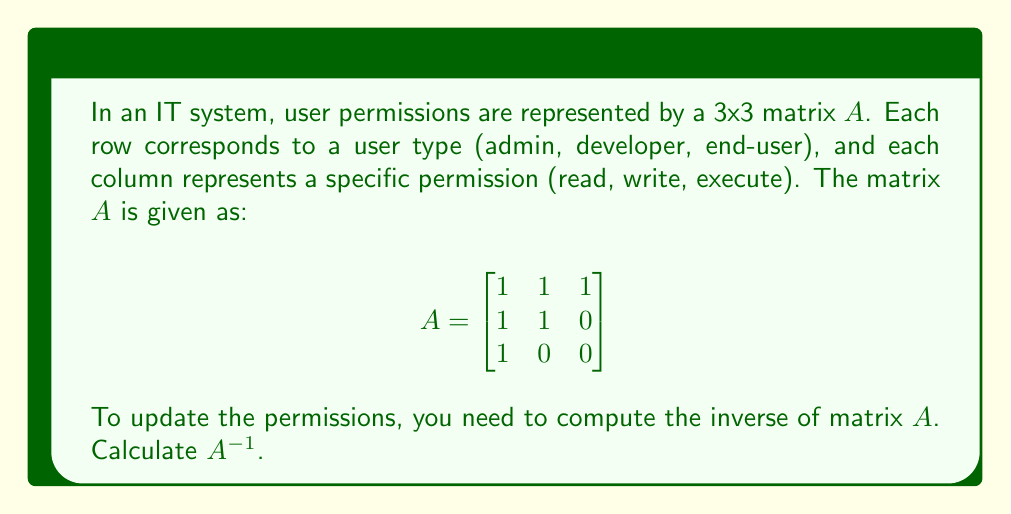Provide a solution to this math problem. To find the inverse of matrix $A$, we'll follow these steps:

1. Calculate the determinant of $A$:
   $det(A) = 1(1\cdot0 - 1\cdot0) - 1(1\cdot0 - 1\cdot1) + 1(1\cdot1 - 1\cdot0) = 0 - (-1) + 1 = 2$

   Since $det(A) \neq 0$, $A$ is invertible.

2. Find the matrix of cofactors:
   $C_{11} = 1\cdot0 - 0\cdot1 = 0$
   $C_{12} = -(1\cdot0 - 0\cdot1) = 0$
   $C_{13} = 1\cdot1 - 1\cdot0 = 1$
   $C_{21} = -(0\cdot0 - 1\cdot1) = -1$
   $C_{22} = 1\cdot0 - 1\cdot1 = -1$
   $C_{23} = -(1\cdot1 - 1\cdot0) = -1$
   $C_{31} = 1\cdot0 - 0\cdot1 = 0$
   $C_{32} = -(1\cdot1 - 1\cdot0) = -1$
   $C_{33} = 1\cdot1 - 1\cdot1 = 0$

3. Create the adjugate matrix by transposing the cofactor matrix:
   $$adj(A) = \begin{bmatrix}
   0 & -1 & 0 \\
   0 & -1 & -1 \\
   1 & -1 & 0
   \end{bmatrix}$$

4. Calculate $A^{-1}$ using the formula: $A^{-1} = \frac{1}{det(A)} \cdot adj(A)$
   $$A^{-1} = \frac{1}{2} \cdot \begin{bmatrix}
   0 & -1 & 0 \\
   0 & -1 & -1 \\
   1 & -1 & 0
   \end{bmatrix}$$

5. Simplify:
   $$A^{-1} = \begin{bmatrix}
   0 & -1/2 & 0 \\
   0 & -1/2 & -1/2 \\
   1/2 & -1/2 & 0
   \end{bmatrix}$$
Answer: $$A^{-1} = \begin{bmatrix}
0 & -1/2 & 0 \\
0 & -1/2 & -1/2 \\
1/2 & -1/2 & 0
\end{bmatrix}$$ 